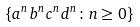<formula> <loc_0><loc_0><loc_500><loc_500>\{ a ^ { n } b ^ { n } c ^ { n } d ^ { n } \colon n \geq 0 \}</formula> 